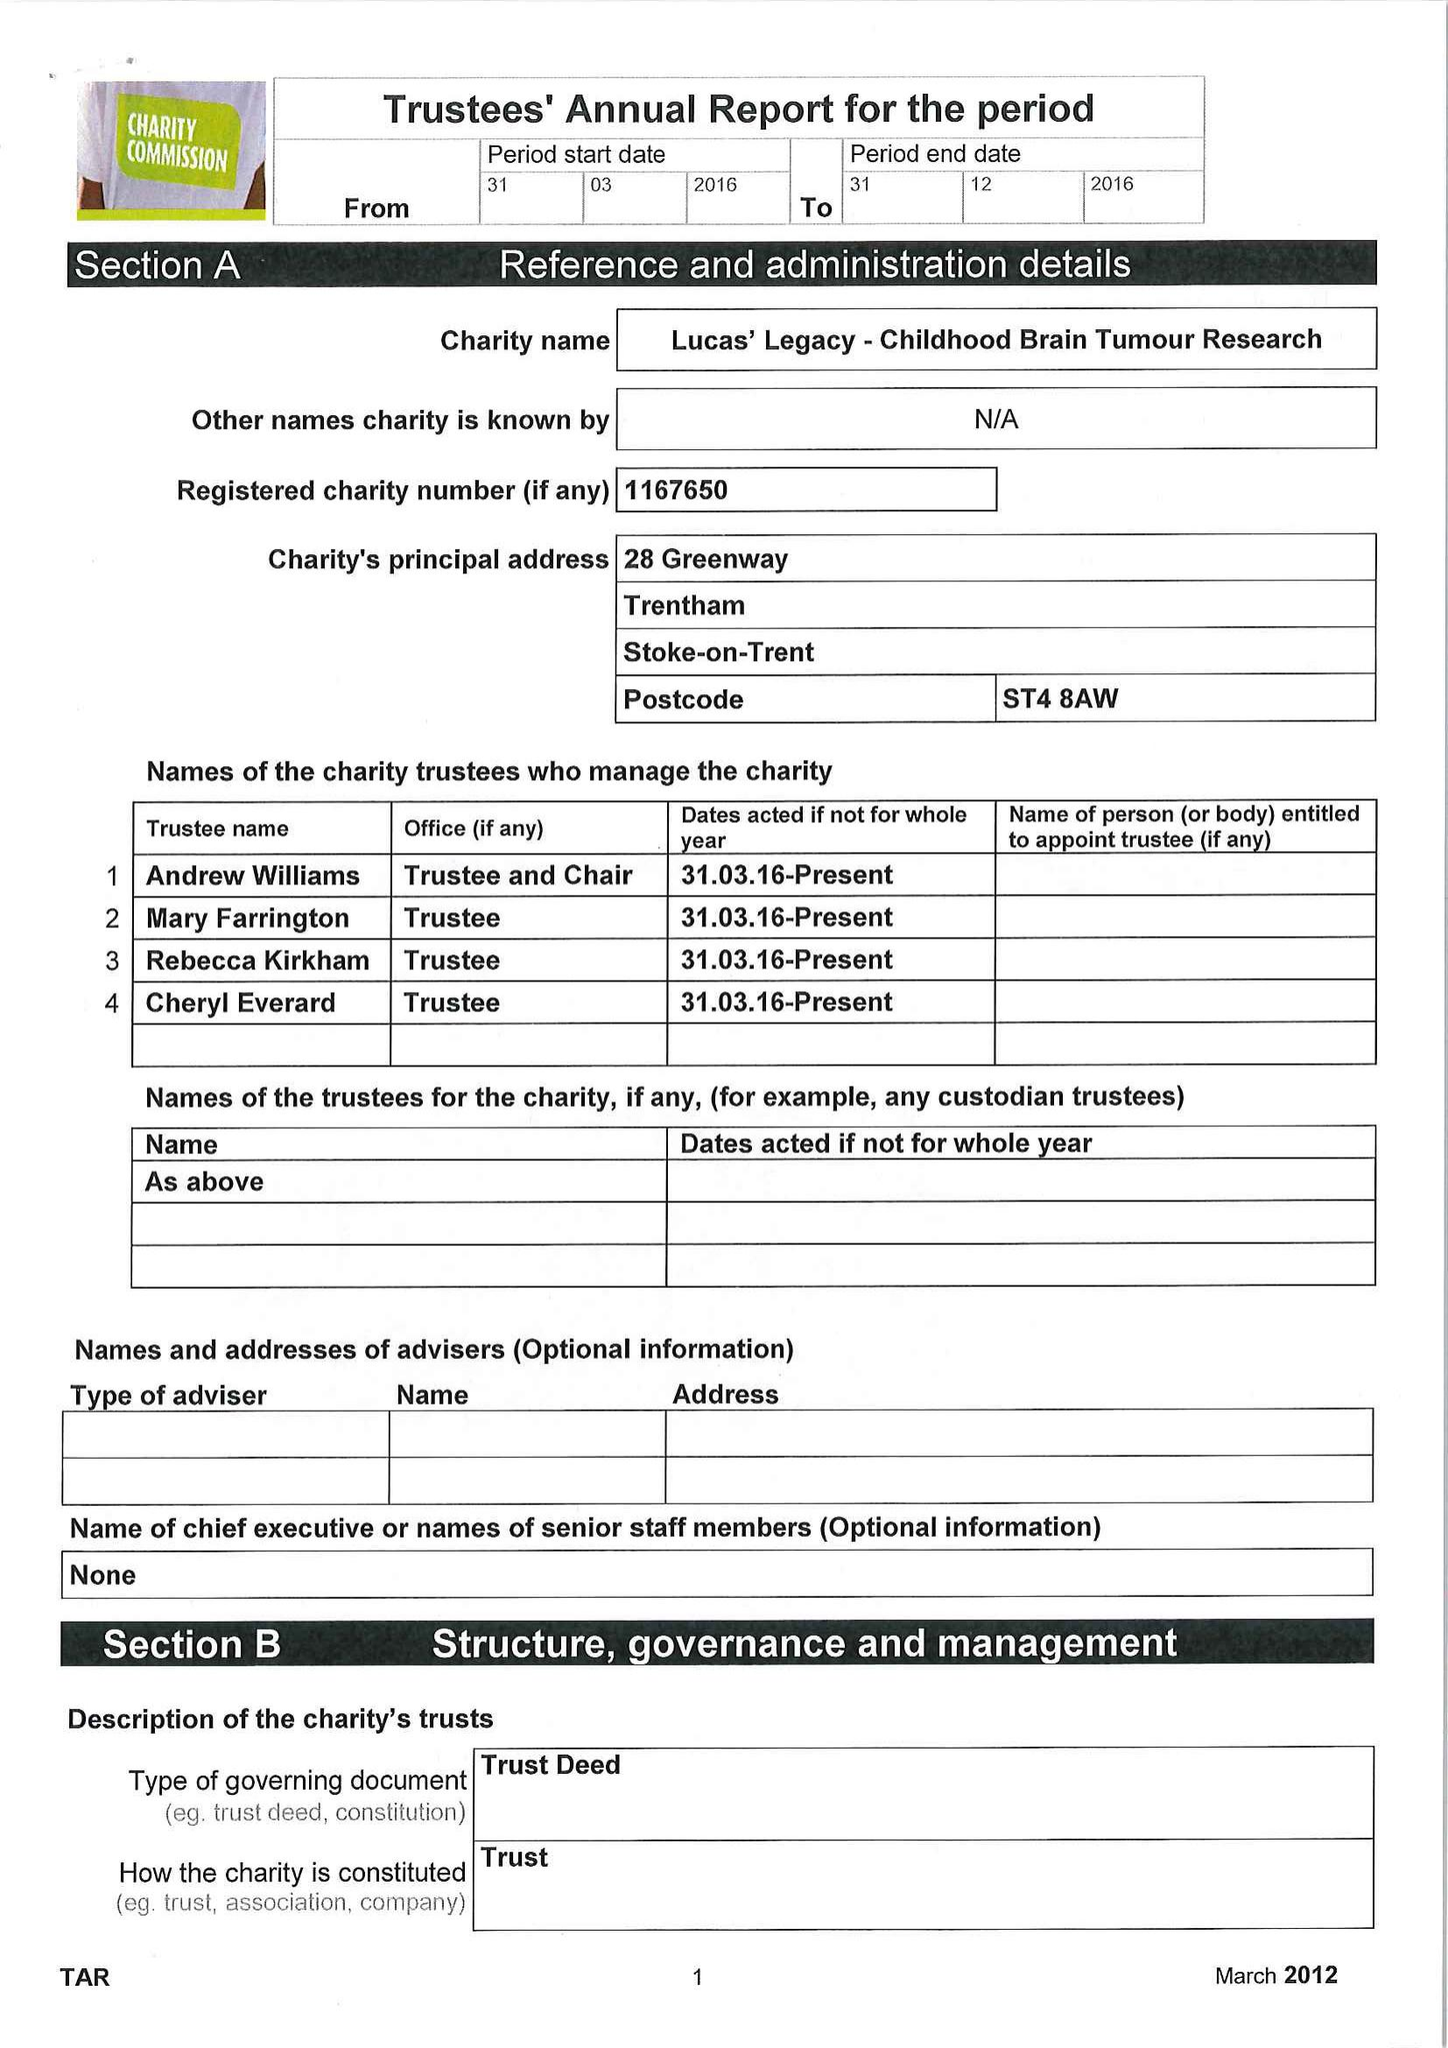What is the value for the income_annually_in_british_pounds?
Answer the question using a single word or phrase. 102585.00 